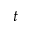Convert formula to latex. <formula><loc_0><loc_0><loc_500><loc_500>t</formula> 